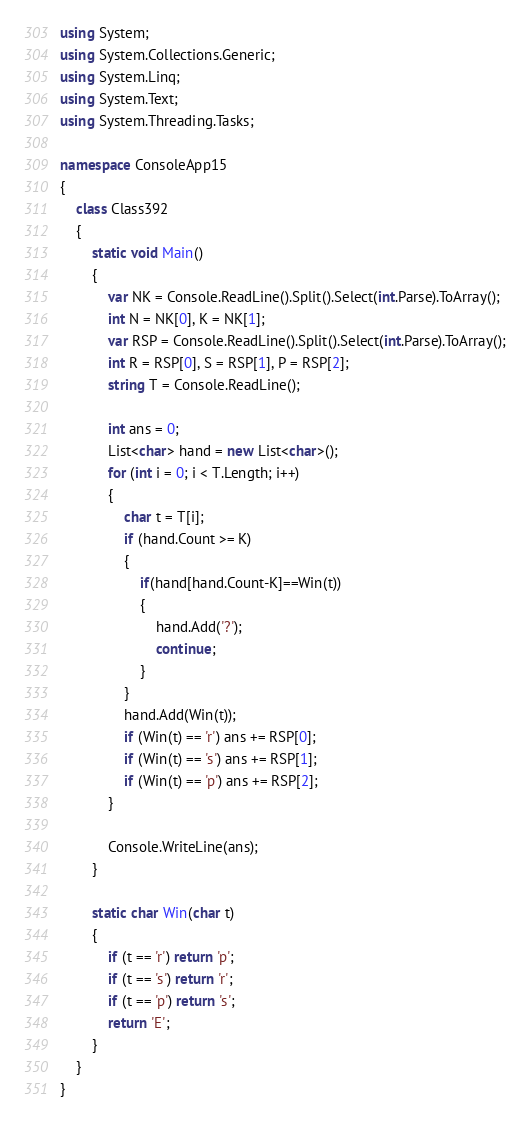Convert code to text. <code><loc_0><loc_0><loc_500><loc_500><_C#_>using System;
using System.Collections.Generic;
using System.Linq;
using System.Text;
using System.Threading.Tasks;

namespace ConsoleApp15
{
    class Class392
    {
        static void Main()
        {
            var NK = Console.ReadLine().Split().Select(int.Parse).ToArray();
            int N = NK[0], K = NK[1];
            var RSP = Console.ReadLine().Split().Select(int.Parse).ToArray();
            int R = RSP[0], S = RSP[1], P = RSP[2];
            string T = Console.ReadLine();

            int ans = 0;
            List<char> hand = new List<char>();
            for (int i = 0; i < T.Length; i++)
            {
                char t = T[i];
                if (hand.Count >= K)
                {
                    if(hand[hand.Count-K]==Win(t))
                    {
                        hand.Add('?');
                        continue;
                    }
                }
                hand.Add(Win(t));
                if (Win(t) == 'r') ans += RSP[0];
                if (Win(t) == 's') ans += RSP[1];
                if (Win(t) == 'p') ans += RSP[2];
            }

            Console.WriteLine(ans);
        }

        static char Win(char t)
        {
            if (t == 'r') return 'p';
            if (t == 's') return 'r';
            if (t == 'p') return 's';
            return 'E';
        }
    }
}
</code> 